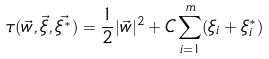<formula> <loc_0><loc_0><loc_500><loc_500>\tau ( \vec { w } , \vec { \xi } , \vec { \xi ^ { * } } ) = \frac { 1 } { 2 } | \vec { w } | ^ { 2 } + C \sum _ { i = 1 } ^ { m } ( \xi _ { i } + \xi _ { i } ^ { * } )</formula> 